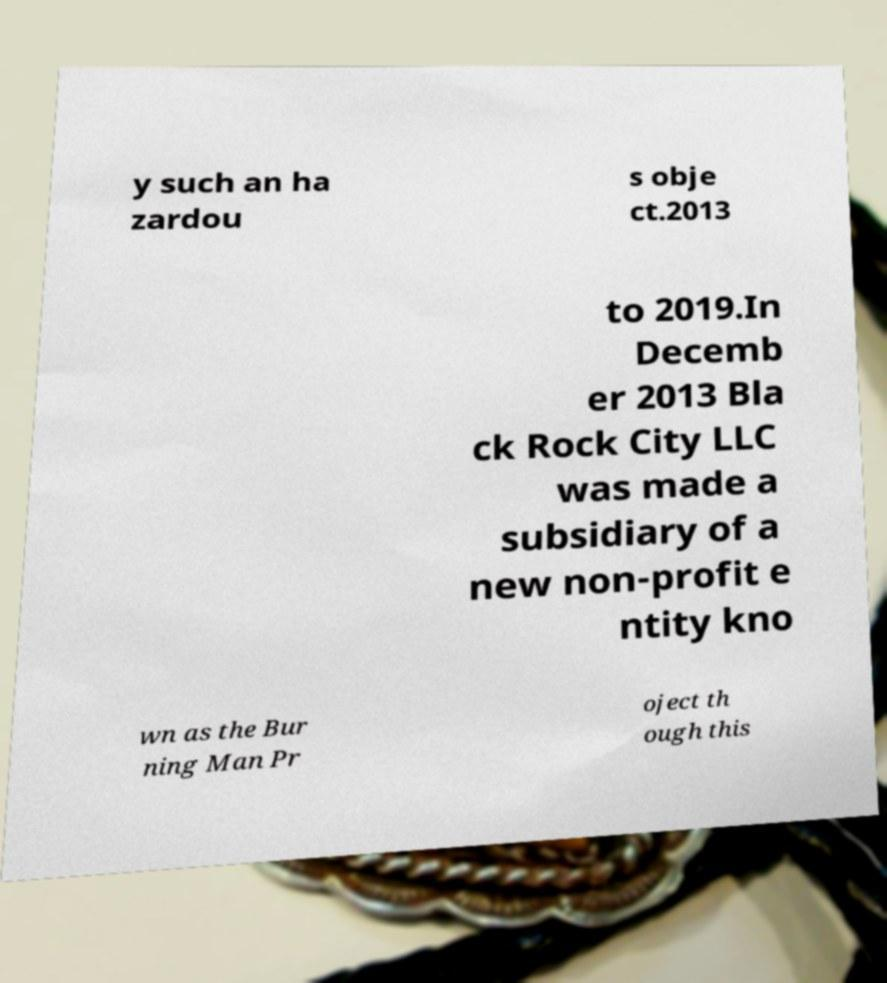Could you extract and type out the text from this image? y such an ha zardou s obje ct.2013 to 2019.In Decemb er 2013 Bla ck Rock City LLC was made a subsidiary of a new non-profit e ntity kno wn as the Bur ning Man Pr oject th ough this 